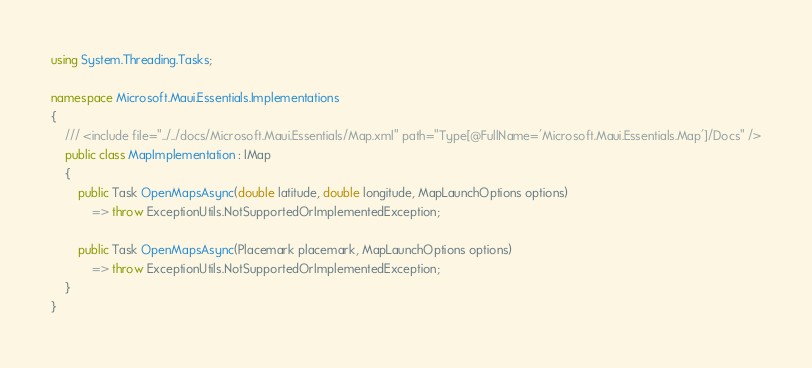<code> <loc_0><loc_0><loc_500><loc_500><_C#_>using System.Threading.Tasks;

namespace Microsoft.Maui.Essentials.Implementations
{
	/// <include file="../../docs/Microsoft.Maui.Essentials/Map.xml" path="Type[@FullName='Microsoft.Maui.Essentials.Map']/Docs" />
	public class MapImplementation : IMap
	{
		public Task OpenMapsAsync(double latitude, double longitude, MapLaunchOptions options)
			=> throw ExceptionUtils.NotSupportedOrImplementedException;

		public Task OpenMapsAsync(Placemark placemark, MapLaunchOptions options)
			=> throw ExceptionUtils.NotSupportedOrImplementedException;
	}
}
</code> 